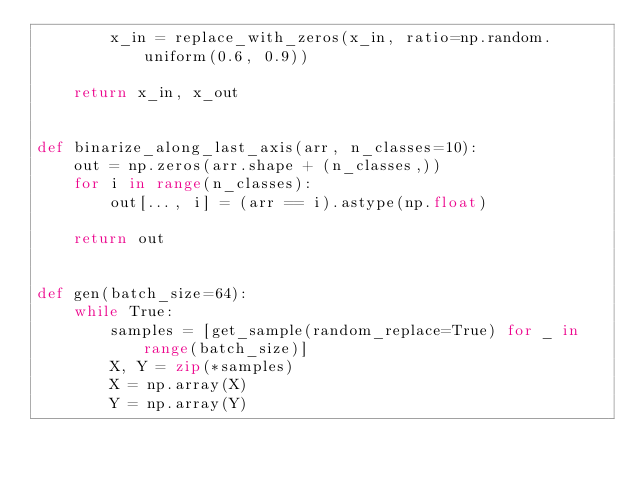<code> <loc_0><loc_0><loc_500><loc_500><_Python_>        x_in = replace_with_zeros(x_in, ratio=np.random.uniform(0.6, 0.9))

    return x_in, x_out


def binarize_along_last_axis(arr, n_classes=10):
    out = np.zeros(arr.shape + (n_classes,))
    for i in range(n_classes):
        out[..., i] = (arr == i).astype(np.float)

    return out


def gen(batch_size=64):
    while True:
        samples = [get_sample(random_replace=True) for _ in range(batch_size)]
        X, Y = zip(*samples)
        X = np.array(X)
        Y = np.array(Y)
</code> 